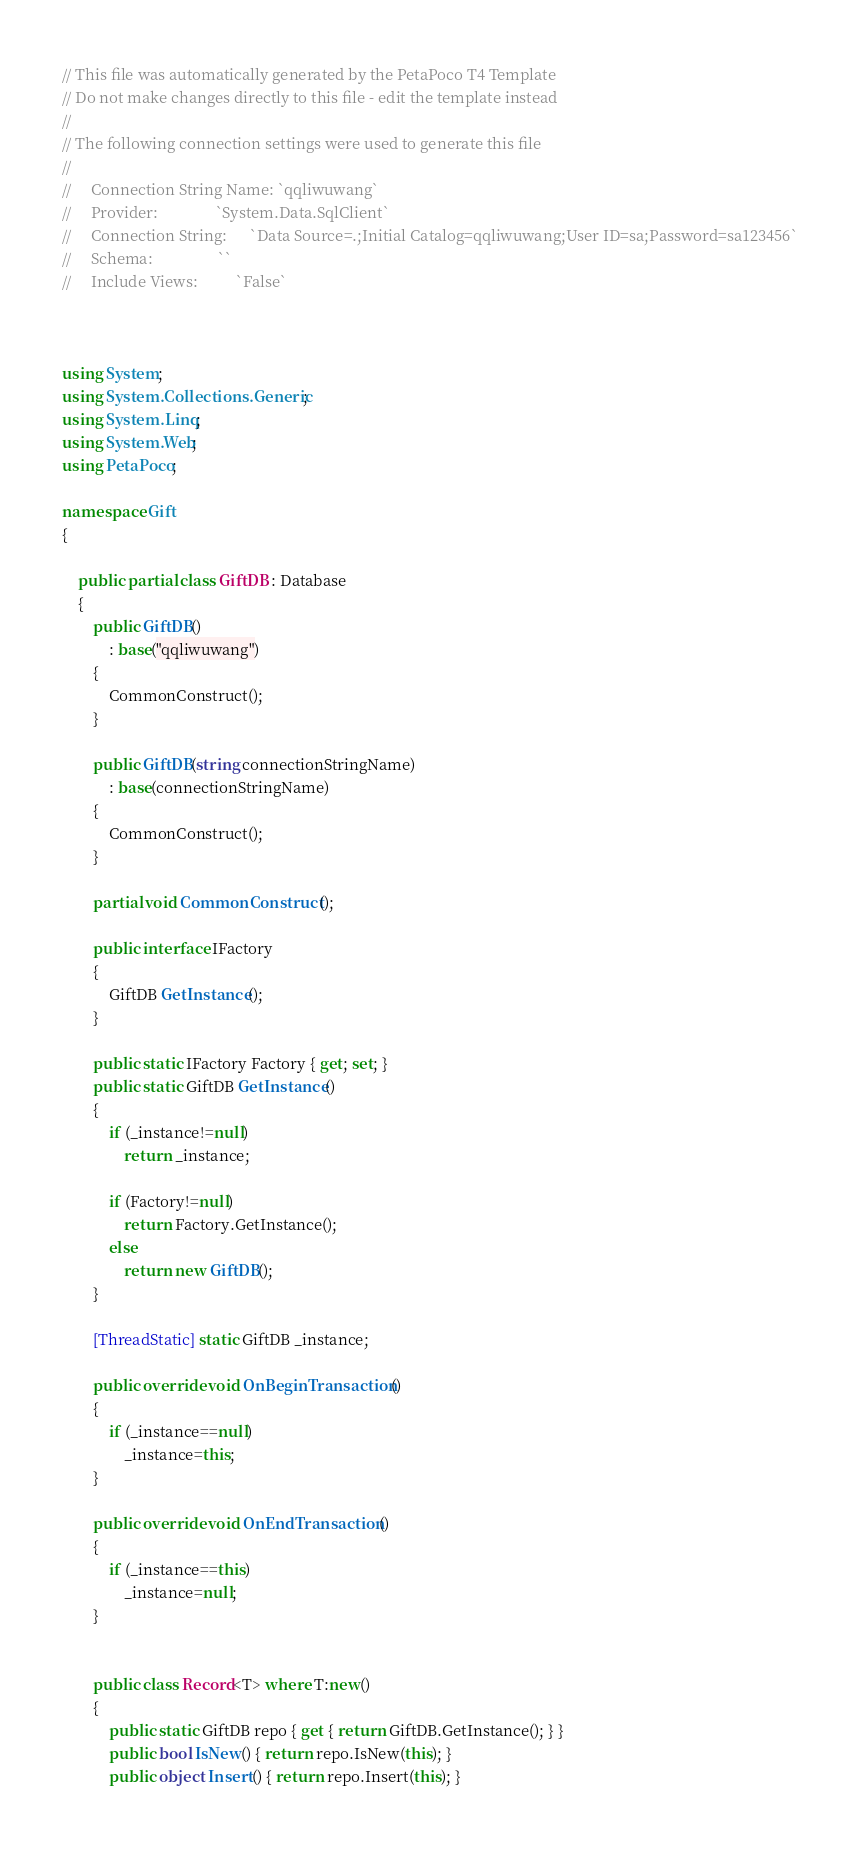<code> <loc_0><loc_0><loc_500><loc_500><_C#_>




















// This file was automatically generated by the PetaPoco T4 Template
// Do not make changes directly to this file - edit the template instead
// 
// The following connection settings were used to generate this file
// 
//     Connection String Name: `qqliwuwang`
//     Provider:               `System.Data.SqlClient`
//     Connection String:      `Data Source=.;Initial Catalog=qqliwuwang;User ID=sa;Password=sa123456`
//     Schema:                 ``
//     Include Views:          `False`



using System;
using System.Collections.Generic;
using System.Linq;
using System.Web;
using PetaPoco;

namespace Gift
{

	public partial class GiftDB : Database
	{
		public GiftDB() 
			: base("qqliwuwang")
		{
			CommonConstruct();
		}

		public GiftDB(string connectionStringName) 
			: base(connectionStringName)
		{
			CommonConstruct();
		}
		
		partial void CommonConstruct();
		
		public interface IFactory
		{
			GiftDB GetInstance();
		}
		
		public static IFactory Factory { get; set; }
        public static GiftDB GetInstance()
        {
			if (_instance!=null)
				return _instance;
				
			if (Factory!=null)
				return Factory.GetInstance();
			else
				return new GiftDB();
        }

		[ThreadStatic] static GiftDB _instance;
		
		public override void OnBeginTransaction()
		{
			if (_instance==null)
				_instance=this;
		}
		
		public override void OnEndTransaction()
		{
			if (_instance==this)
				_instance=null;
		}
        

		public class Record<T> where T:new()
		{
			public static GiftDB repo { get { return GiftDB.GetInstance(); } }
			public bool IsNew() { return repo.IsNew(this); }
			public object Insert() { return repo.Insert(this); }
</code> 